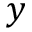<formula> <loc_0><loc_0><loc_500><loc_500>y</formula> 